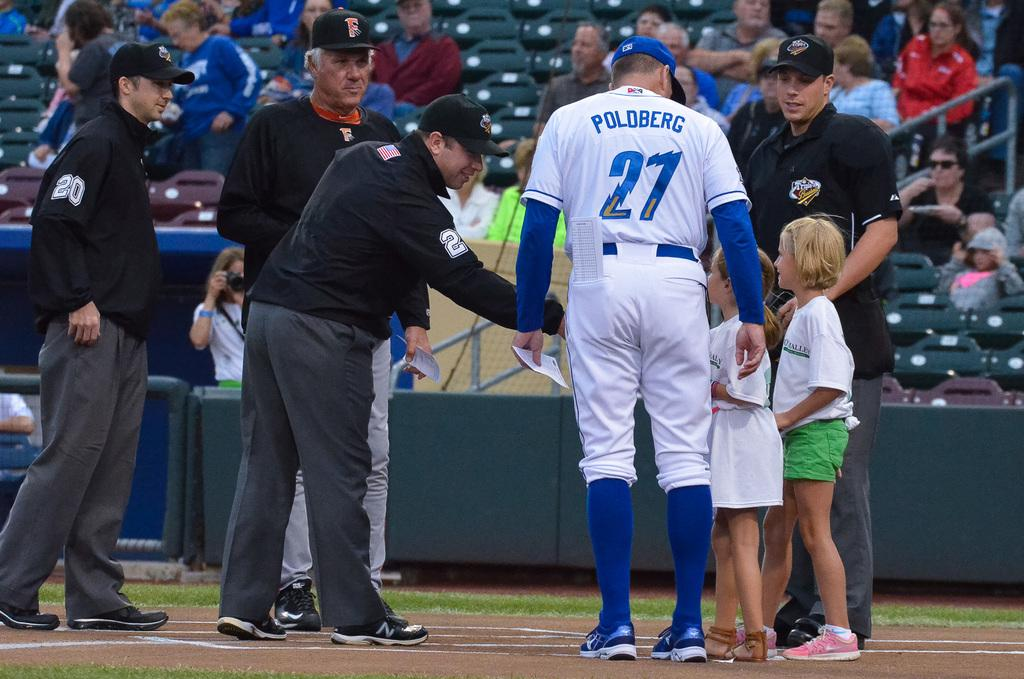<image>
Summarize the visual content of the image. Baseball player wearing number 27 talking to some children. 